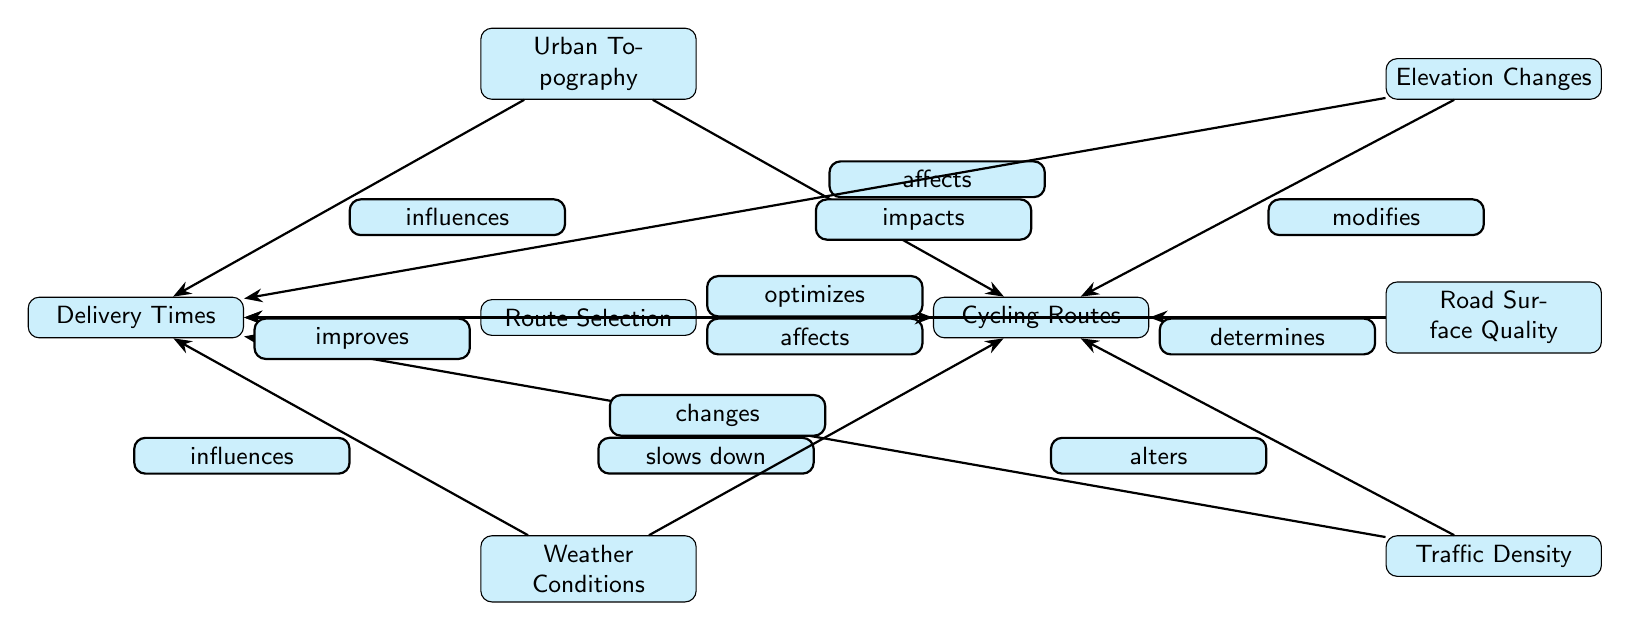What's the main focus of the diagram? The central node indicates that the main focus of the diagram is "Urban Topography." This is the starting point from which connections to other nodes are made.
Answer: Urban Topography How many factors affect cycling routes? The diagram shows five different factors that affect cycling routes: elevation changes, road surface quality, traffic density, weather conditions, and route selection. This can be counted directly from the connections emanating from the "Cycling Routes" node.
Answer: Five What does elevation do to cycling routes? The diagram indicates that "Elevation Changes" modifies cycling routes. This is directly illustrated by the arrow from the "Elevation Changes" node to the "Cycling Routes" node.
Answer: Modifies Which factor slows down delivery times? The diagram shows that "Traffic Density" slows down delivery times, as indicated by the edge labeled "slows down" connecting "Traffic Density" to "Delivery Times."
Answer: Traffic Density How many influences are shown from urban topography to cycling routes and delivery times? The diagram shows one influence, labeled "affects," from "Urban Topography" to "Cycling Routes," and another influence, labeled "influences," from "Urban Topography" to "Delivery Times." Thus, there are two distinct influences.
Answer: Two What affects delivery times apart from urban topography? According to the diagram, several factors besides urban topography affect delivery times: elevation changes, road surface quality, weather conditions, and traffic density. There are four factors mentioned in total that connect to "Delivery Times."
Answer: Four What role does route selection play in cycling routes? The diagram indicates that "Route Selection" optimizes cycling routes, which is explicitly expressed in the label on the connection to "Cycling Routes."
Answer: Optimizes How many edges are there between cycling routes and delivery times? The diagram reveals three distinct edges connecting the "Cycling Routes" node to others affecting delivery times: from "Road Surface Quality," "Traffic Density," and "Weather Conditions." Therefore, there are three edges directly influencing delivery times.
Answer: Three Which factor changes cycling routes? The diagram clearly indicates that "Weather Conditions" changes cycling routes, as represented by the connecting edge labeled "changes" leading to the "Cycling Routes" node.
Answer: Weather Conditions 